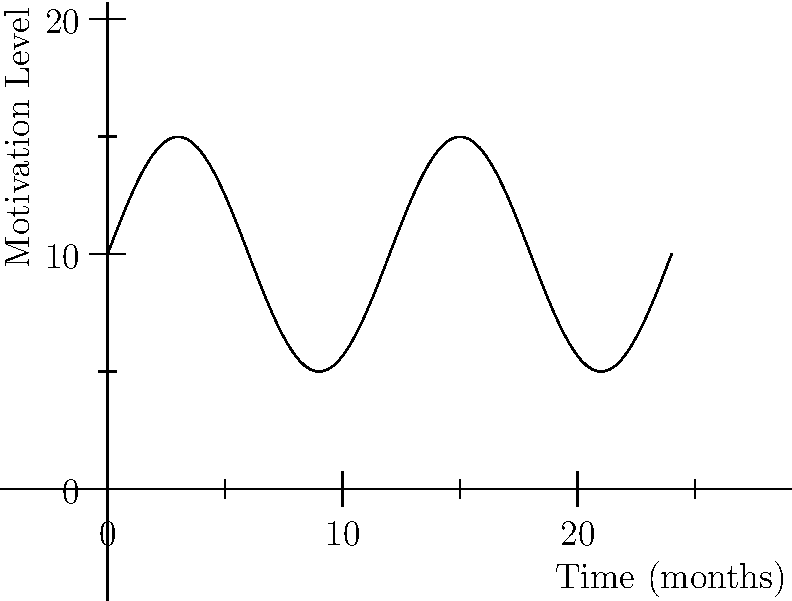As an organizational psychologist, you're analyzing employee motivation cycles over a 2-year period. The motivation level $M$ can be modeled by the function $M(t) = 5\sin(\frac{\pi t}{6}) + 10$, where $t$ is time in months. What is the period of this motivation cycle in months, and how many complete cycles occur within the 2-year timeframe? To solve this problem, we need to follow these steps:

1. Determine the period of the sine function:
   The general form of a sine function is $f(t) = A\sin(Bt) + C$, where $\frac{2\pi}{B}$ is the period.
   In our case, $M(t) = 5\sin(\frac{\pi t}{6}) + 10$
   So, $B = \frac{\pi}{6}$

   Period = $\frac{2\pi}{B} = \frac{2\pi}{\frac{\pi}{6}} = 12$ months

2. Calculate the number of complete cycles in 2 years:
   2 years = 24 months
   Number of cycles = $\frac{\text{Total time}}{\text{Period}} = \frac{24}{12} = 2$ cycles

Therefore, the period of the motivation cycle is 12 months, and there are 2 complete cycles within the 2-year timeframe.
Answer: Period: 12 months; Complete cycles: 2 